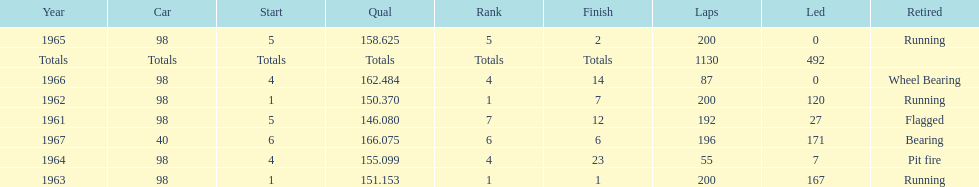How many times did he finish in the top three? 2. 